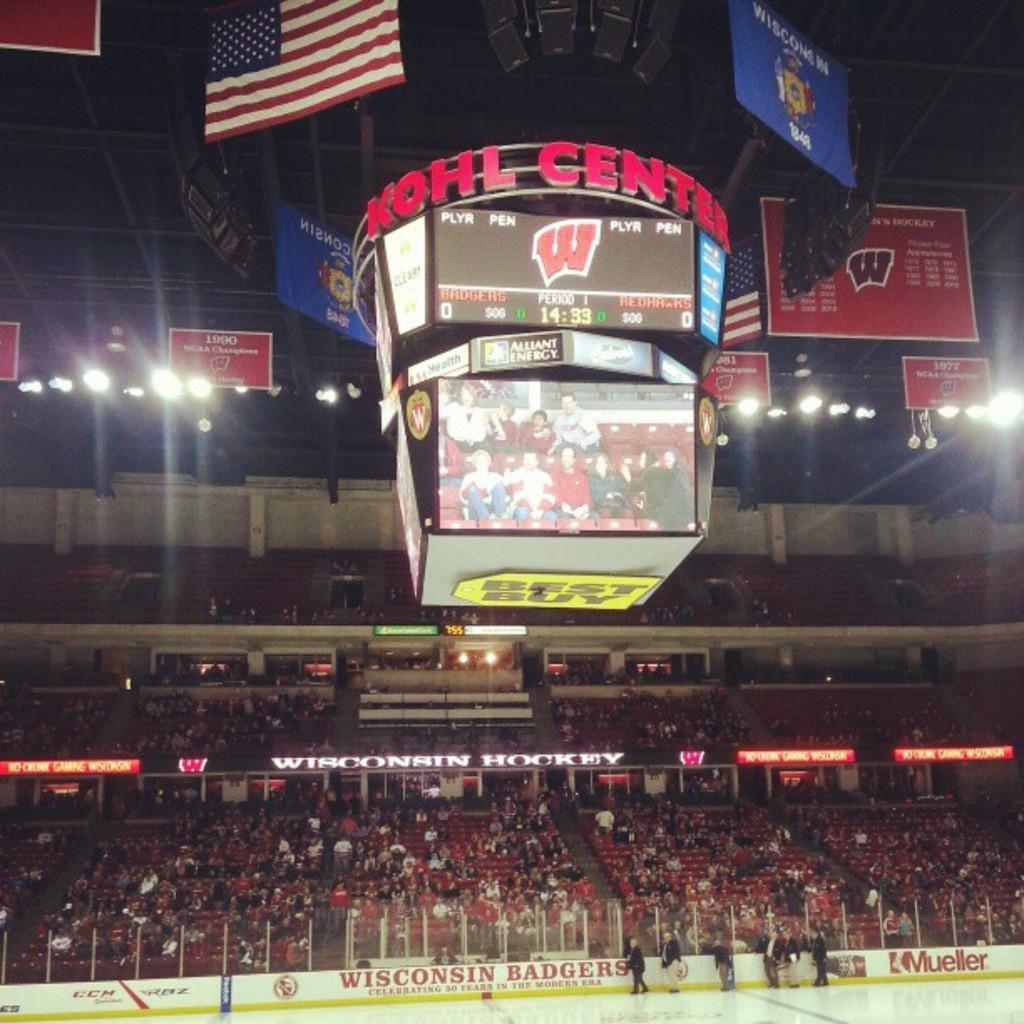<image>
Present a compact description of the photo's key features. A sparse crowd attends a game of hockey at the Kohl Center. 